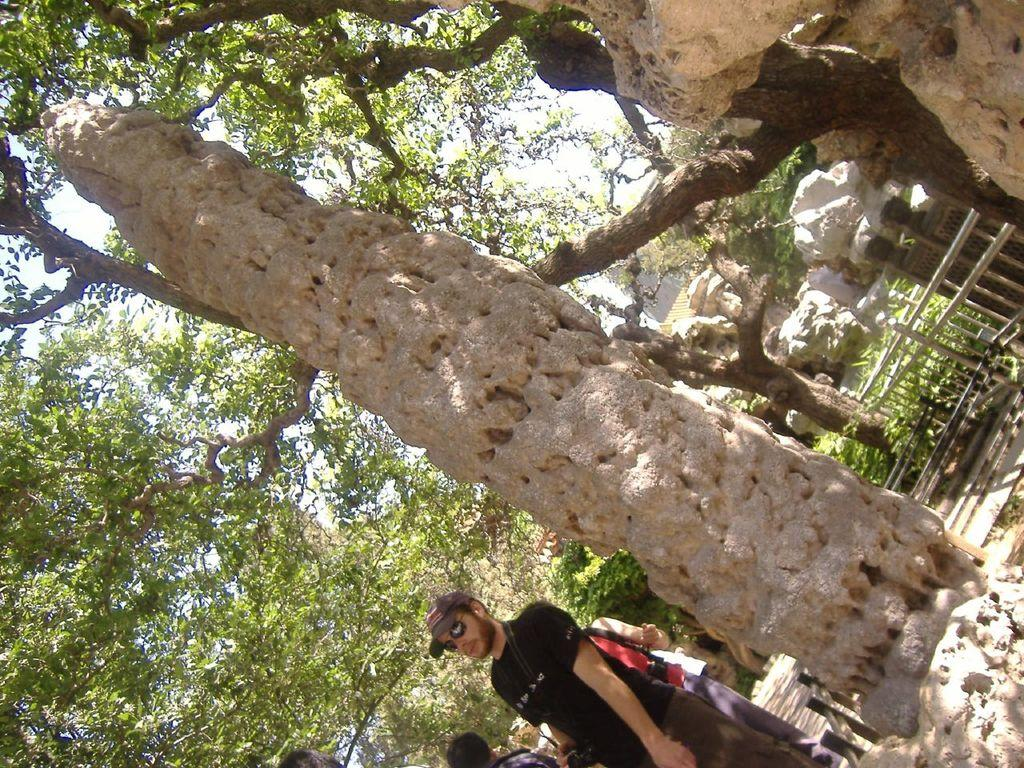What are the people in the image doing? The people in the image are walking on the ground. What structure can be seen in the image? There is a stone pole in the image. What type of barrier is present in the image? There is a fence in the image. What type of vegetation is visible in the image? There are trees in the image. What type of natural material is present on the ground? There are stones in the image. What can be seen in the background of the image? The sky is visible in the background of the image. What type of sail can be seen on the skirt in the image? There is no sail or skirt present in the image; it features people walking on the ground, a stone pole, a fence, trees, stones, and the sky in the background. 